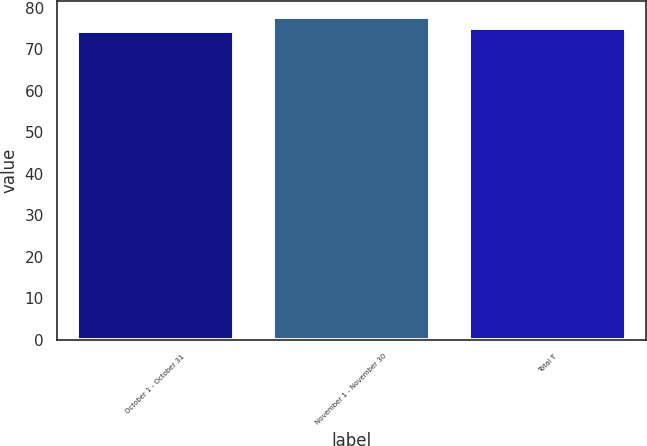Convert chart. <chart><loc_0><loc_0><loc_500><loc_500><bar_chart><fcel>October 1 - October 31<fcel>November 1 - November 30<fcel>Total T<nl><fcel>74.37<fcel>77.77<fcel>74.99<nl></chart> 